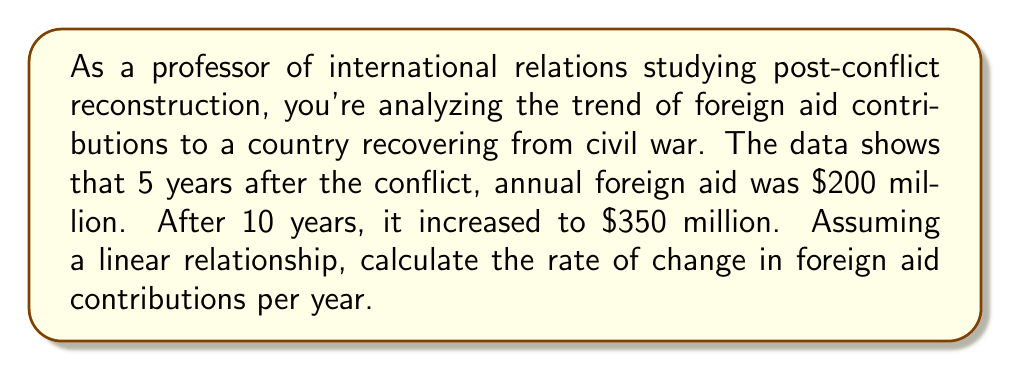Can you solve this math problem? To solve this problem, we'll use the linear equation formula:

$$y = mx + b$$

Where:
$m$ = rate of change (slope)
$x$ = time in years
$y$ = foreign aid in millions of dollars
$b$ = y-intercept (initial value)

We have two points:
$(x_1, y_1) = (5, 200)$
$(x_2, y_2) = (10, 350)$

To find the rate of change (slope), we use the formula:

$$m = \frac{y_2 - y_1}{x_2 - x_1}$$

Plugging in our values:

$$m = \frac{350 - 200}{10 - 5} = \frac{150}{5} = 30$$

Therefore, the rate of change in foreign aid contributions is $30 million per year.

To verify, we can use this rate to calculate the change over the 5-year period:
$30 \text{ million/year} \times 5 \text{ years} = 150 \text{ million}$

This matches the observed increase from $200 million to $350 million over the 5-year period.
Answer: The rate of change in foreign aid contributions is $30 million per year. 